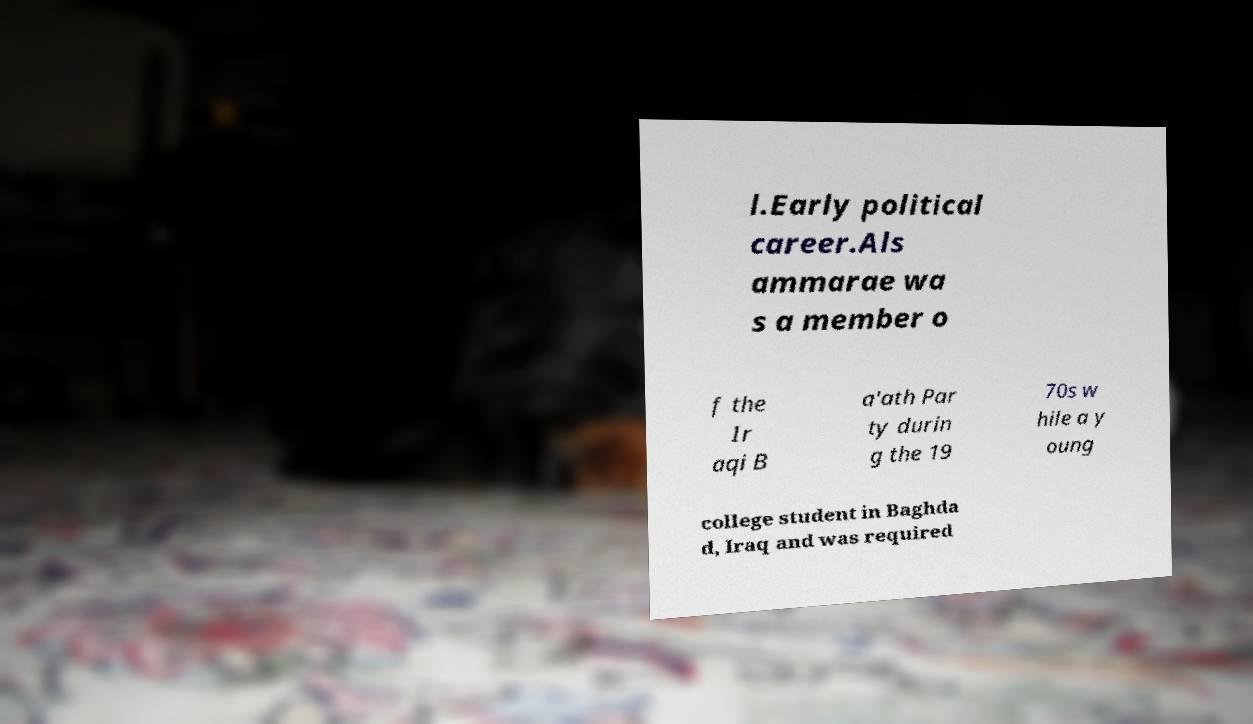Can you accurately transcribe the text from the provided image for me? l.Early political career.Als ammarae wa s a member o f the Ir aqi B a'ath Par ty durin g the 19 70s w hile a y oung college student in Baghda d, Iraq and was required 